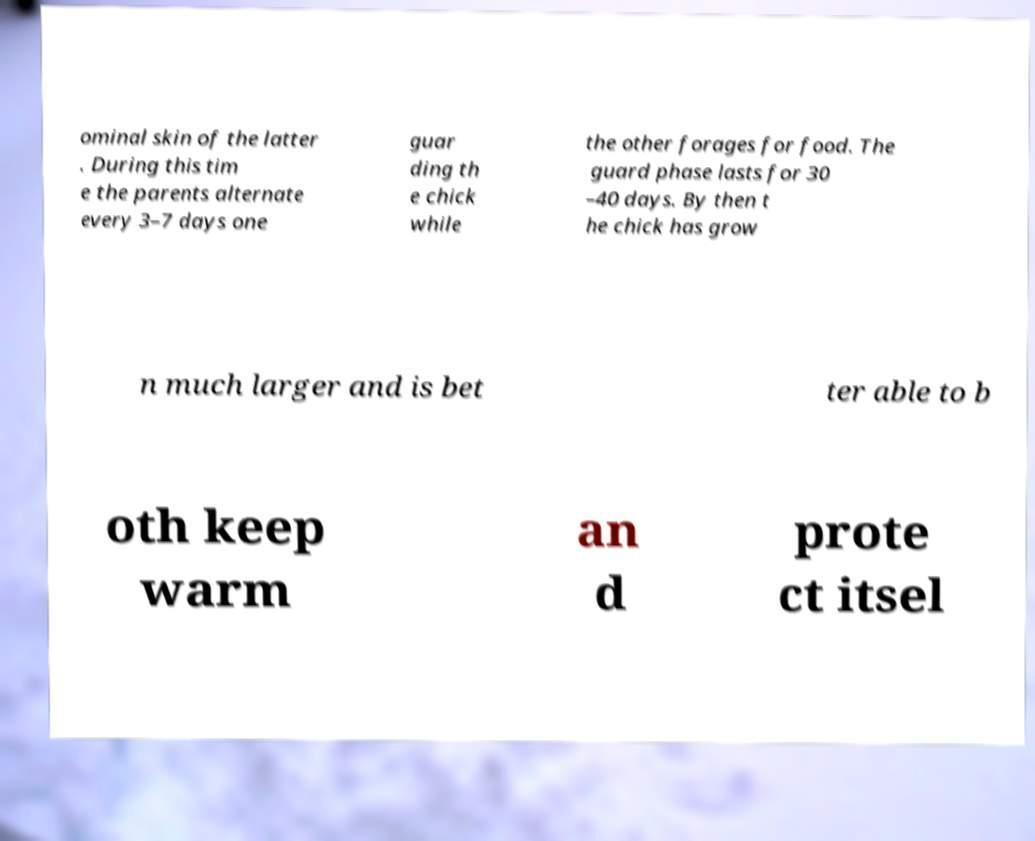Could you extract and type out the text from this image? ominal skin of the latter . During this tim e the parents alternate every 3–7 days one guar ding th e chick while the other forages for food. The guard phase lasts for 30 –40 days. By then t he chick has grow n much larger and is bet ter able to b oth keep warm an d prote ct itsel 